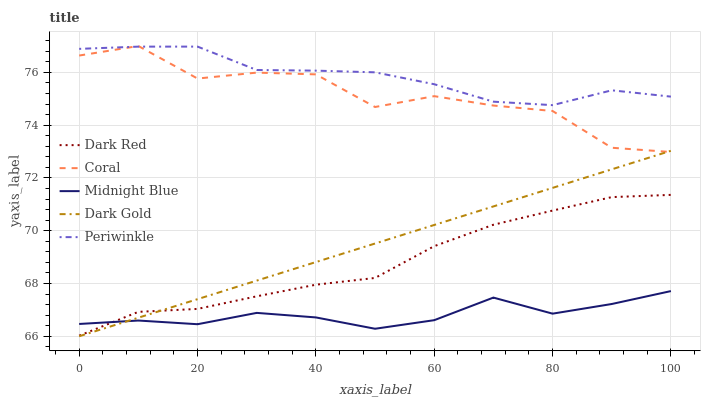Does Midnight Blue have the minimum area under the curve?
Answer yes or no. Yes. Does Coral have the minimum area under the curve?
Answer yes or no. No. Does Coral have the maximum area under the curve?
Answer yes or no. No. Is Periwinkle the smoothest?
Answer yes or no. No. Is Periwinkle the roughest?
Answer yes or no. No. Does Coral have the lowest value?
Answer yes or no. No. Does Periwinkle have the highest value?
Answer yes or no. No. Is Dark Red less than Coral?
Answer yes or no. Yes. Is Coral greater than Dark Red?
Answer yes or no. Yes. Does Dark Red intersect Coral?
Answer yes or no. No. 